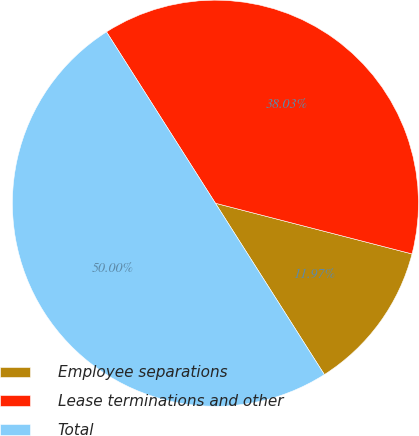<chart> <loc_0><loc_0><loc_500><loc_500><pie_chart><fcel>Employee separations<fcel>Lease terminations and other<fcel>Total<nl><fcel>11.97%<fcel>38.03%<fcel>50.0%<nl></chart> 